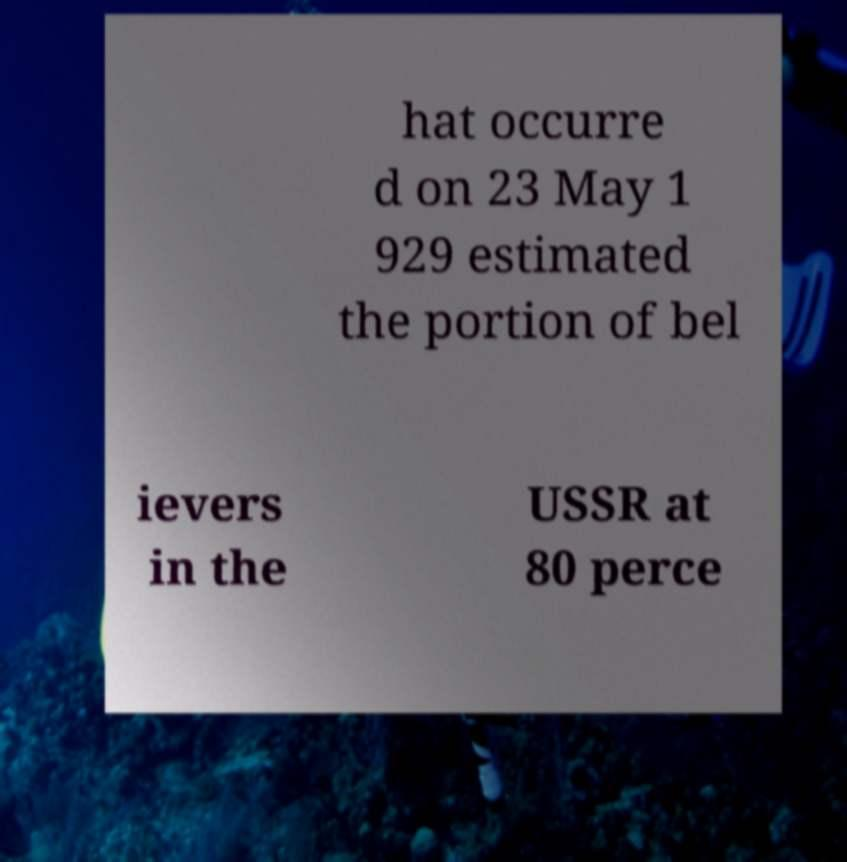There's text embedded in this image that I need extracted. Can you transcribe it verbatim? hat occurre d on 23 May 1 929 estimated the portion of bel ievers in the USSR at 80 perce 